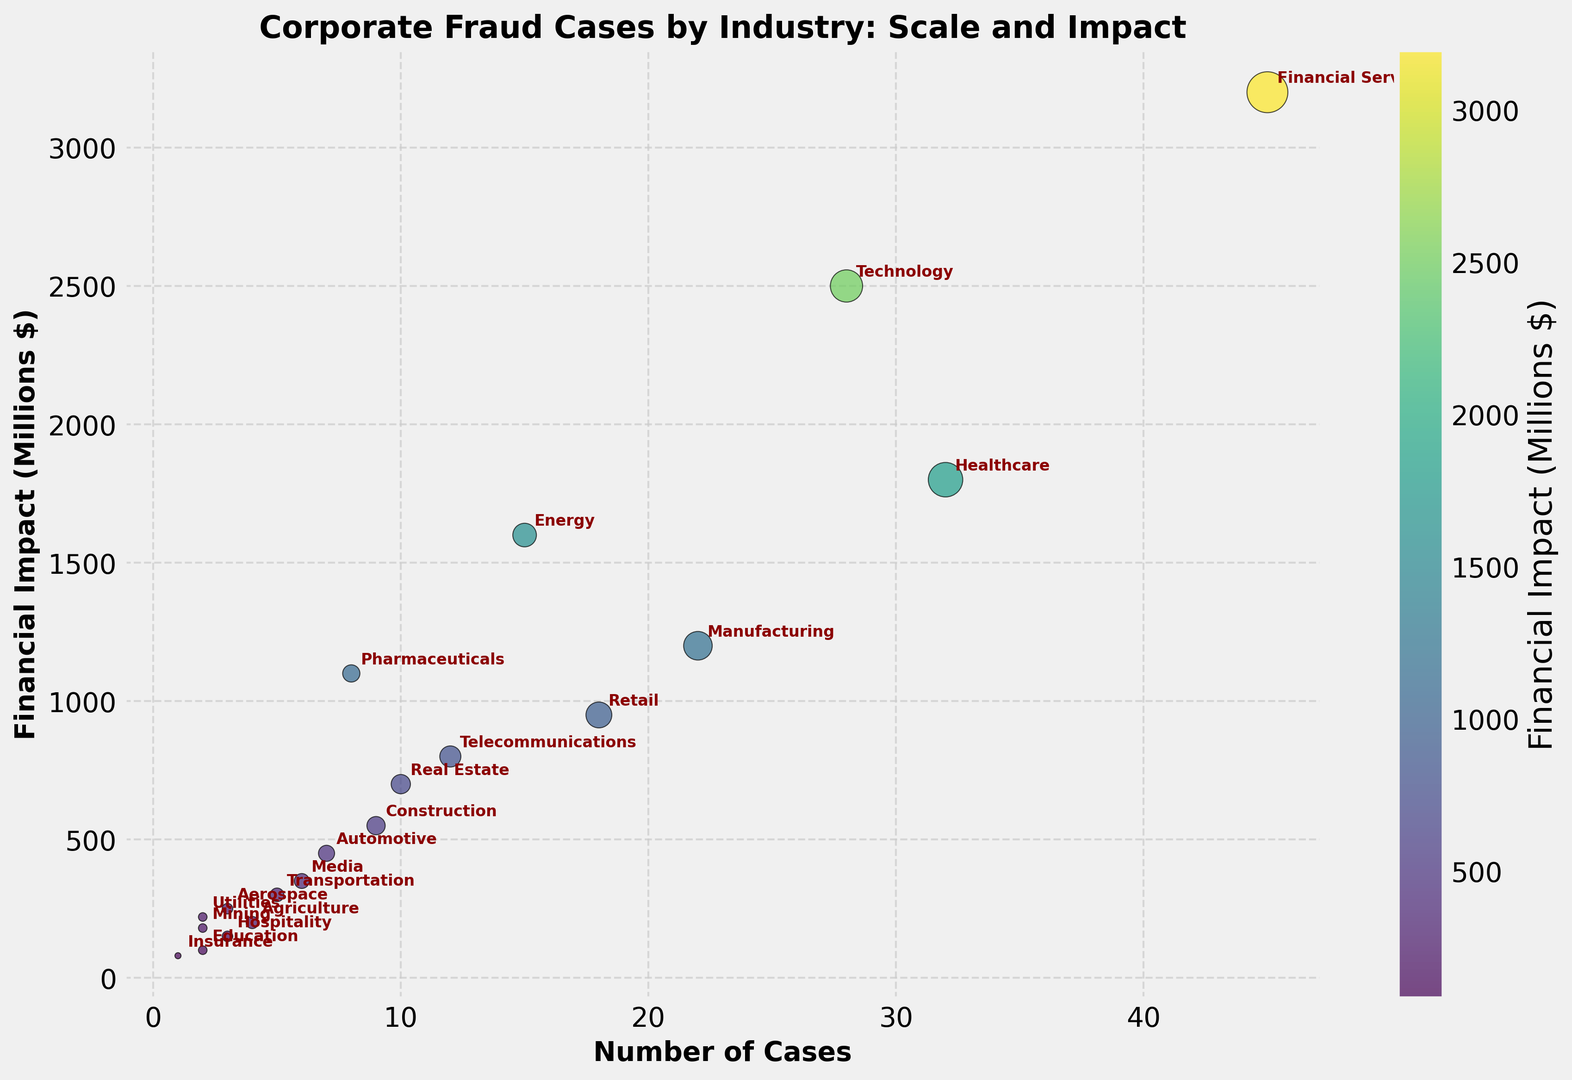Which industry has the highest financial impact? The scatter plot indicates the "Financial Services" industry has the highest financial impact, visualized by its position on the y-axis.
Answer: Financial Services Which industry has the least number of fraud cases? By observing the x-axis for the smallest number of cases, the "Insurance" industry has the least number of fraud cases.
Answer: Insurance How does the financial impact of the Energy industry compare to that of the Healthcare industry? The "Energy" industry has a financial impact of 1600 million dollars, while the "Healthcare" industry has a financial impact of 1800 million dollars. Thus, Healthcare has a higher financial impact.
Answer: Healthcare has a higher financial impact How many more cases does the Telecommunications industry have compared to the Automotive industry? Telecommunications has 12 cases, and Automotive has 7 cases. The difference in the number of cases is 12 - 7 = 5.
Answer: 5 more cases Which industry sector has the highest financial impact per case, given that Financial Impact per Case = Financial_Impact_Millions / Cases? To find the highest financial impact per case, divide the financial impact by the number of cases for each industry. Financial Services ($3200M / 45 cases ≈ 71.11), Healthcare ($1800M / 32 cases ≈ 56.25), and so forth. From the visual inspection, it turns out the Energy industry ($1600M / 15 cases ≈ 106.67) appears to have the highest impact per case.
Answer: Energy What is the total financial impact of the Financial Services and Technology industries combined? Financial Services has a financial impact of $3200 million, and Technology has a financial impact of $2500 million. The combined financial impact is 3200 + 2500 = 5700 million dollars.
Answer: 5700 million dollars Which two industries have similar financial impacts but different numbers of cases? Observing the scatter plot, the Technology and Pharmaceuticals industries have close financial impacts of $2500 million and $1100 million, but Technology has 28 cases compared to Pharmaceuticals with 8 cases. This illustrates different numbers of cases with similar impacts.
Answer: Technology and Pharmaceuticals What is the median number of fraud cases among the listed industries? To find the median, list the number of cases in ascending order and find the middle value. Sorting the cases: 1, 2, 2, 2, 3, 3, 4, 5, 6, 7, 8, 9, 10, 12, 15, 18, 22, 28, 32, 45. The median of 20 numbers is the average of the 10th and 11th values: (7 + 8) / 2 = 7.5 cases.
Answer: 7.5 cases What is the average financial impact across all industries? Sum all the financial impacts and divide by the number of industries. Sum = 3200 + 1800 + 2500 + 1200 + 950 + 1600 + 800 + 700 + 550 + 1100 + 450 + 350 + 300 + 200 + 150 + 250 + 100 + 180 + 220 + 80 = 18680 million dollars. Number of industries = 20. The average is 18680 / 20 = 934 million dollars.
Answer: 934 million dollars 